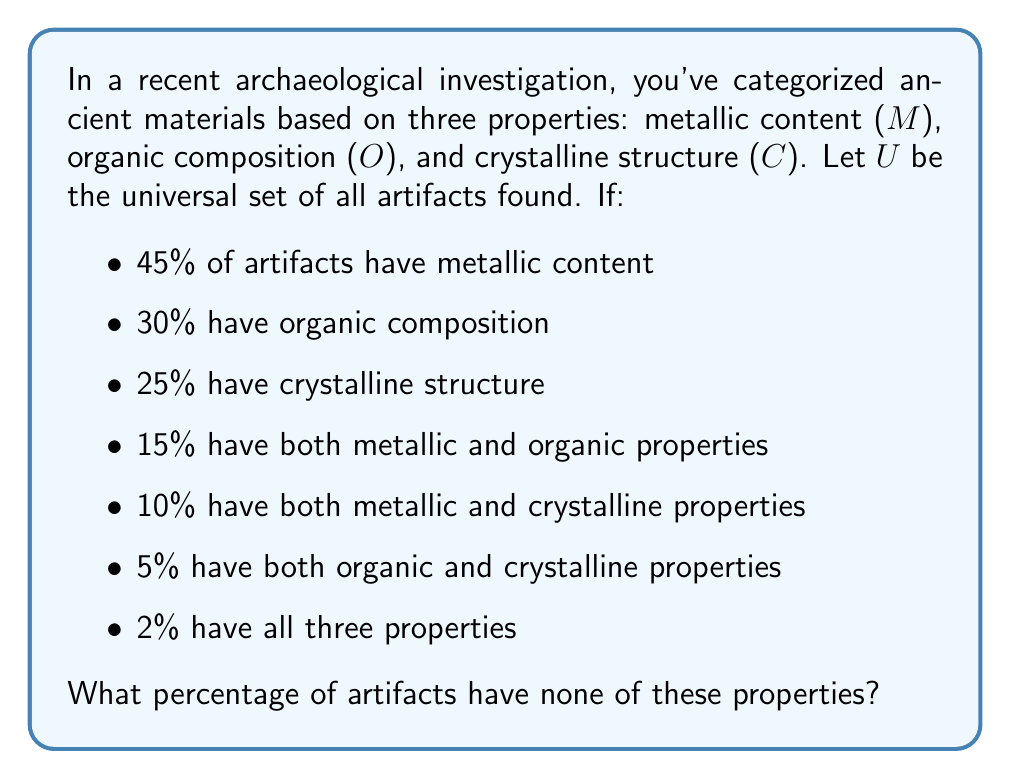Teach me how to tackle this problem. To solve this problem, we'll use the Inclusion-Exclusion Principle from set theory. Let's break it down step-by-step:

1) First, let's define our sets:
   $M$: artifacts with metallic content
   $O$: artifacts with organic composition
   $C$: artifacts with crystalline structure

2) We're given the following information:
   $P(M) = 0.45$
   $P(O) = 0.30$
   $P(C) = 0.25$
   $P(M \cap O) = 0.15$
   $P(M \cap C) = 0.10$
   $P(O \cap C) = 0.05$
   $P(M \cap O \cap C) = 0.02$

3) The Inclusion-Exclusion Principle states:
   $P(M \cup O \cup C) = P(M) + P(O) + P(C) - P(M \cap O) - P(M \cap C) - P(O \cap C) + P(M \cap O \cap C)$

4) Let's substitute our values:
   $P(M \cup O \cup C) = 0.45 + 0.30 + 0.25 - 0.15 - 0.10 - 0.05 + 0.02 = 0.72$

5) This means that 72% of artifacts have at least one of these properties.

6) Therefore, the percentage of artifacts with none of these properties is:
   $1 - P(M \cup O \cup C) = 1 - 0.72 = 0.28$

Thus, 28% of artifacts have none of these properties.
Answer: 28% 